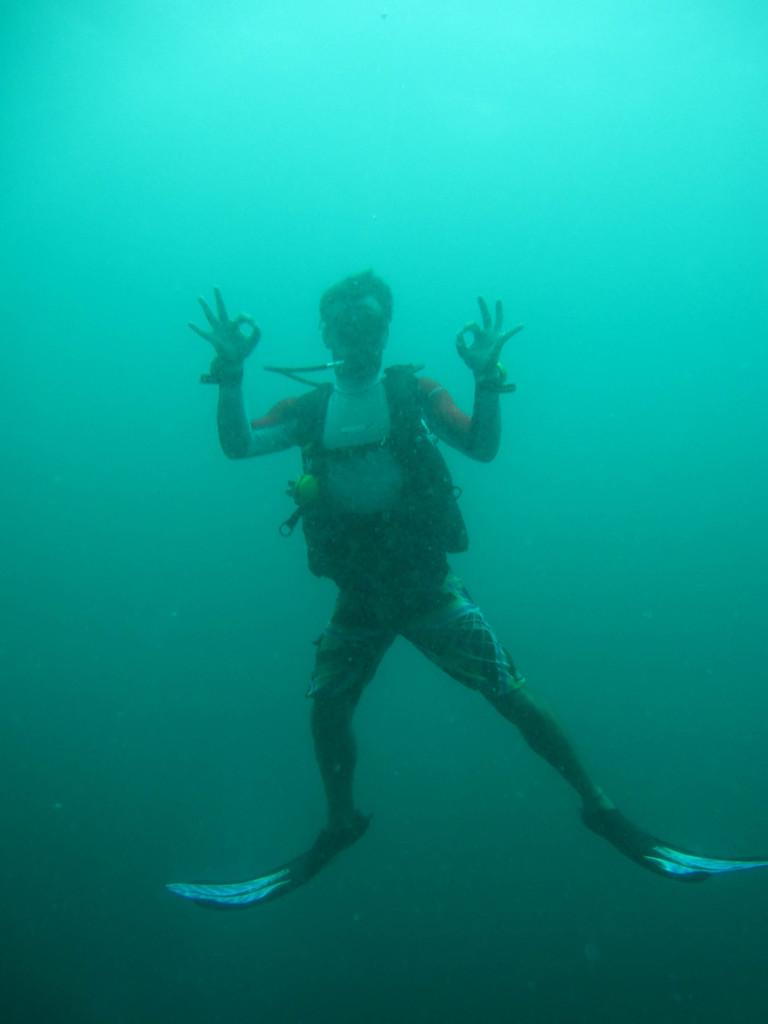What is present in the image? There is a person in the image. What can be seen in the background of the image? There is water visible in the background of the image. Where is the playground located in the image? There is no playground present in the image. Who is the friend of the person in the image? The image does not show any friends of the person, as only one person is visible. 